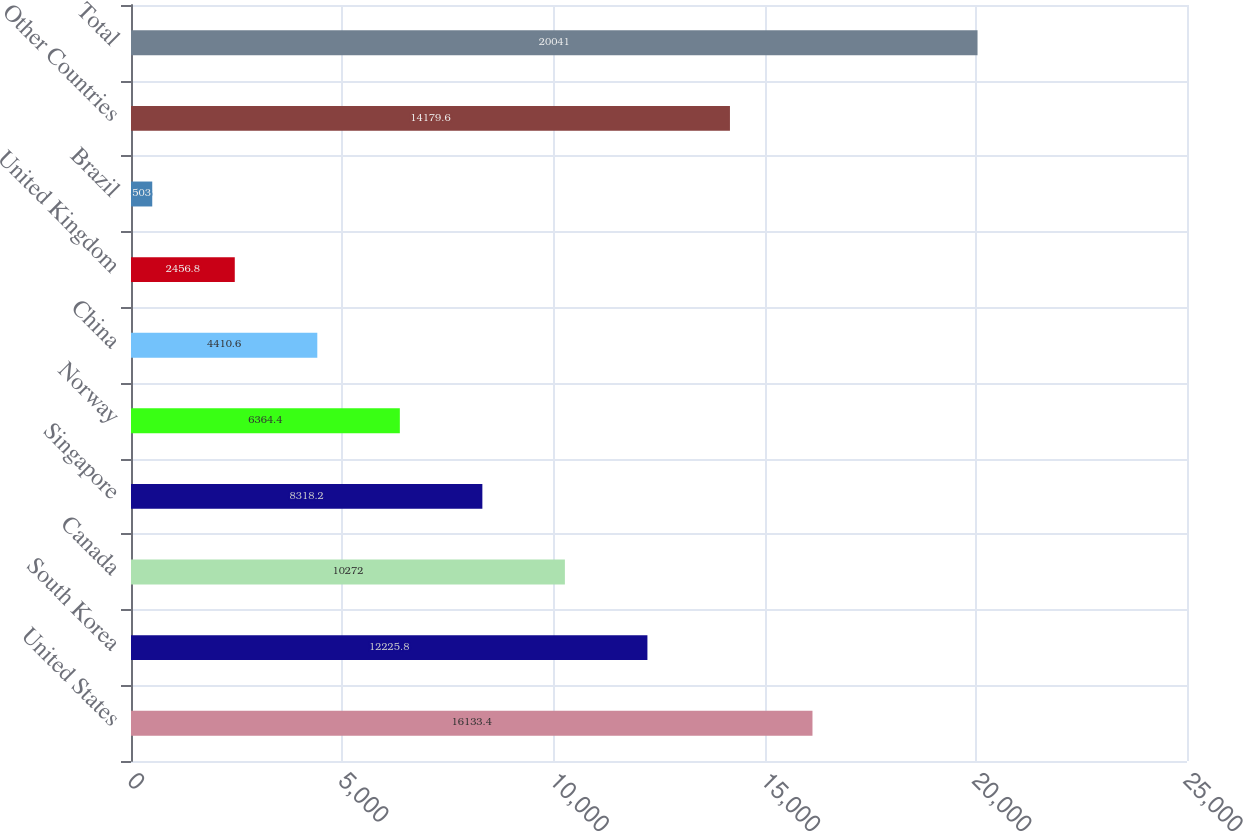<chart> <loc_0><loc_0><loc_500><loc_500><bar_chart><fcel>United States<fcel>South Korea<fcel>Canada<fcel>Singapore<fcel>Norway<fcel>China<fcel>United Kingdom<fcel>Brazil<fcel>Other Countries<fcel>Total<nl><fcel>16133.4<fcel>12225.8<fcel>10272<fcel>8318.2<fcel>6364.4<fcel>4410.6<fcel>2456.8<fcel>503<fcel>14179.6<fcel>20041<nl></chart> 